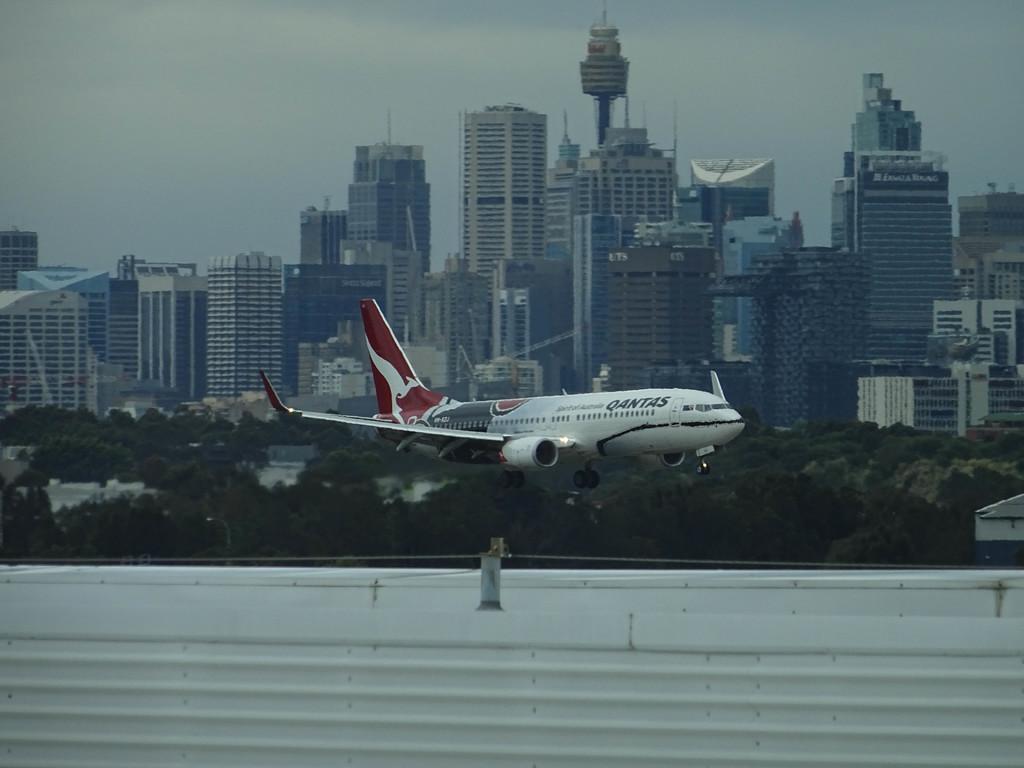How would you summarize this image in a sentence or two? In the image there is an airplane flying and behind the airplane there are a lot of buildings and trees. 